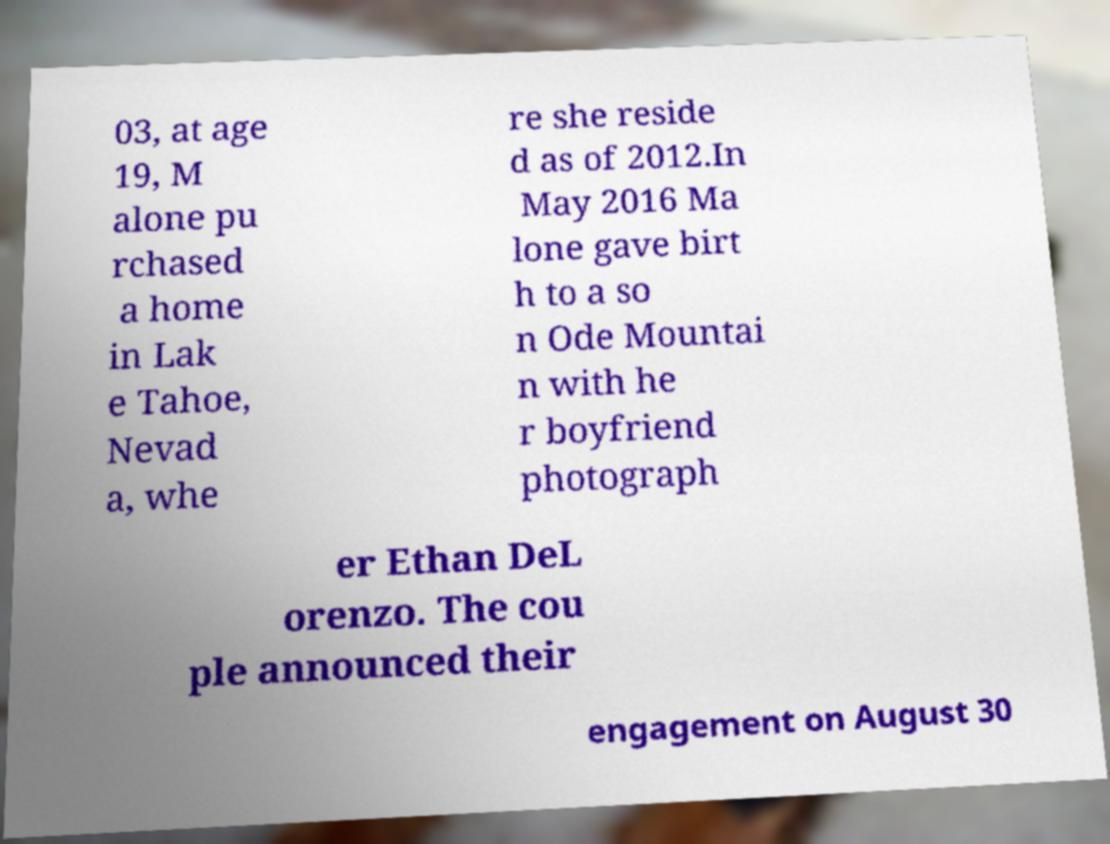What messages or text are displayed in this image? I need them in a readable, typed format. 03, at age 19, M alone pu rchased a home in Lak e Tahoe, Nevad a, whe re she reside d as of 2012.In May 2016 Ma lone gave birt h to a so n Ode Mountai n with he r boyfriend photograph er Ethan DeL orenzo. The cou ple announced their engagement on August 30 